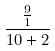Convert formula to latex. <formula><loc_0><loc_0><loc_500><loc_500>\frac { \frac { 9 } { 1 } } { 1 0 + 2 }</formula> 